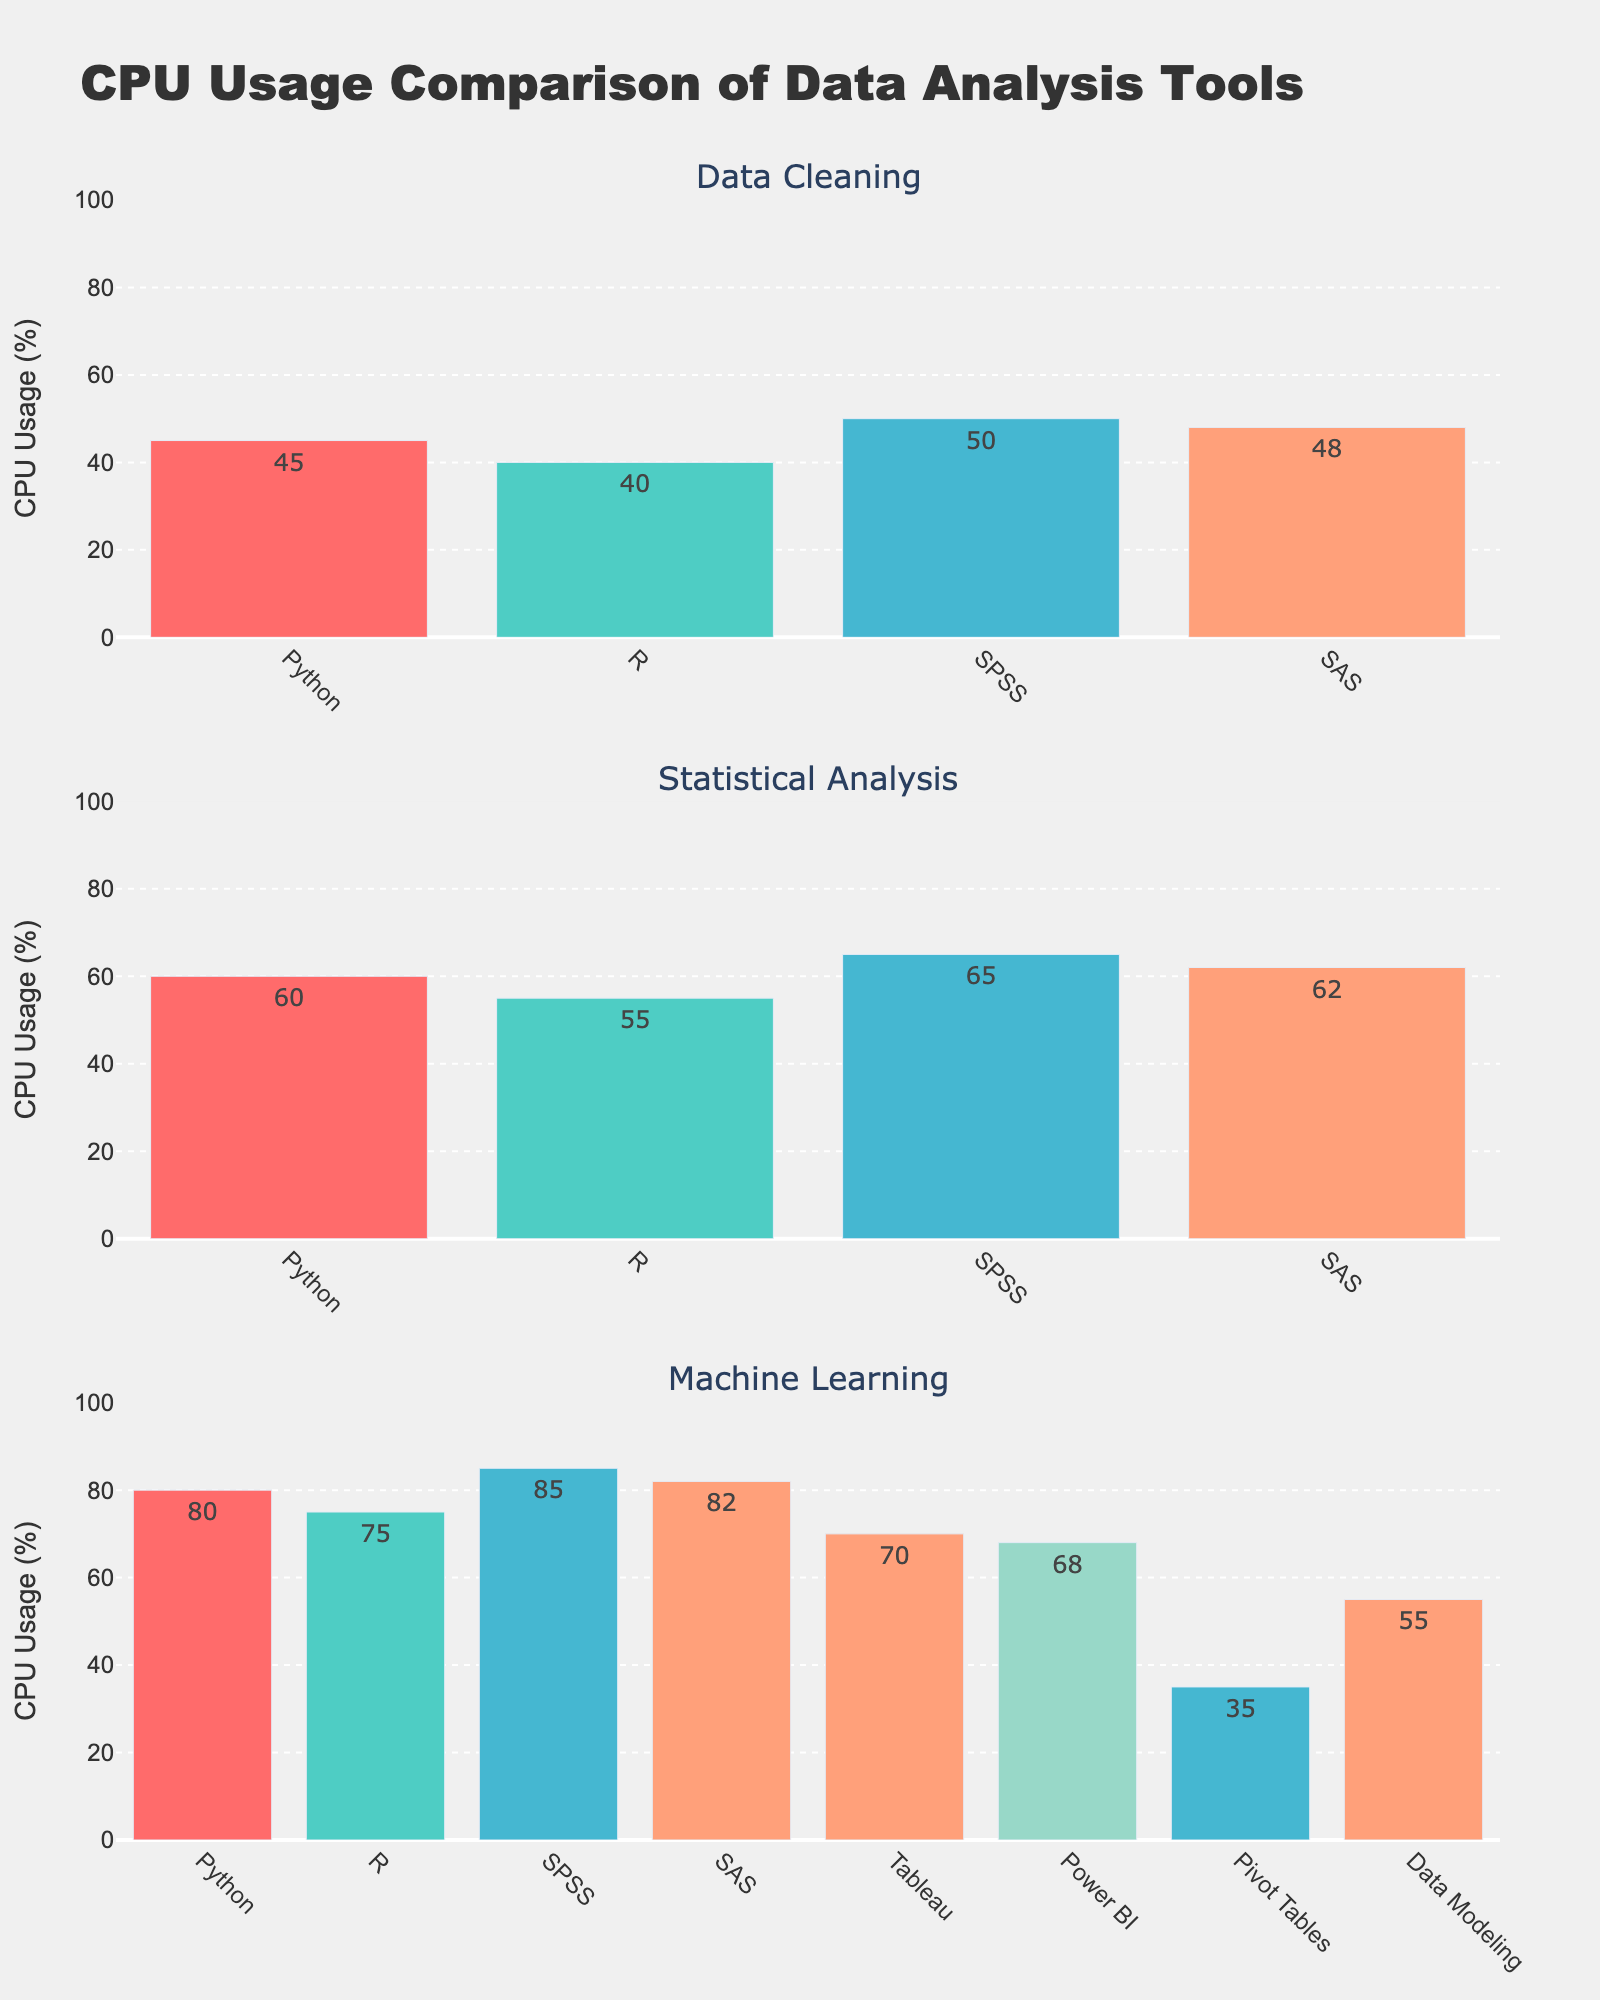What's the title of the figure? The title of the figure is displayed prominently at the top and reads "CPU Usage Comparison of Data Analysis Tools".
Answer: CPU Usage Comparison of Data Analysis Tools Which tool has the highest CPU usage for Machine Learning? By examining the "Machine Learning" subplot, we can see that SPSS has the highest CPU usage percentage, indicated by the tallest bar in this subplot.
Answer: SPSS What is the range of CPU usage percentages on the y-axis? The y-axis range is clearly labeled, displaying a span from 0% to 100% with intervals of 20%.
Answer: 0% to 100% What tool has the lowest CPU usage for Data Cleaning? By looking at the "Data Cleaning" subplot, R has the lowest CPU usage, indicated by the shortest bar.
Answer: R What is the sum of CPU Usage percentages for Data Visualization tools? Summing up the CPU usage percentages for Tableau (70%) and Power BI (68%) gives 70% + 68% = 138%.
Answer: 138% Which operation has the highest average CPU usage across all tools? Calculating the average CPU usage for each operation:
- Data Cleaning: (45% + 40% + 50% + 48%) / 4 = 45.75%
- Statistical Analysis: (60% + 55% + 65%+ 62%) / 4 = 60.5%
- Machine Learning: (80% + 75% + 85% + 82%) / 4 = 80.5%
- Data Visualization: (70% + 68%) / 2 = 69%
- Pivot Tables: 35%
- Data Modeling: 55%
The highest average CPU usage is for Machine Learning at 80.5%.
Answer: Machine Learning Which tool has a higher CPU usage for Statistical Analysis, SPSS or SAS? Comparing the CPU usage percentages in the "Statistical Analysis" subplot, SPSS has 65% and SAS has 62%. SPSS has the higher CPU usage.
Answer: SPSS What is the difference in CPU usage between Python and SPSS for Statistical Analysis? In the "Statistical Analysis" subplot, Python's CPU usage is 60% and SPSS's is 65%. The difference is 65% - 60% = 5%.
Answer: 5% How many Excel operations are shown in the figure? The "Excel Operations" subplot shows two operations: Pivot Tables and Data Modeling, as indicated by the two bars in the plot.
Answer: 2 